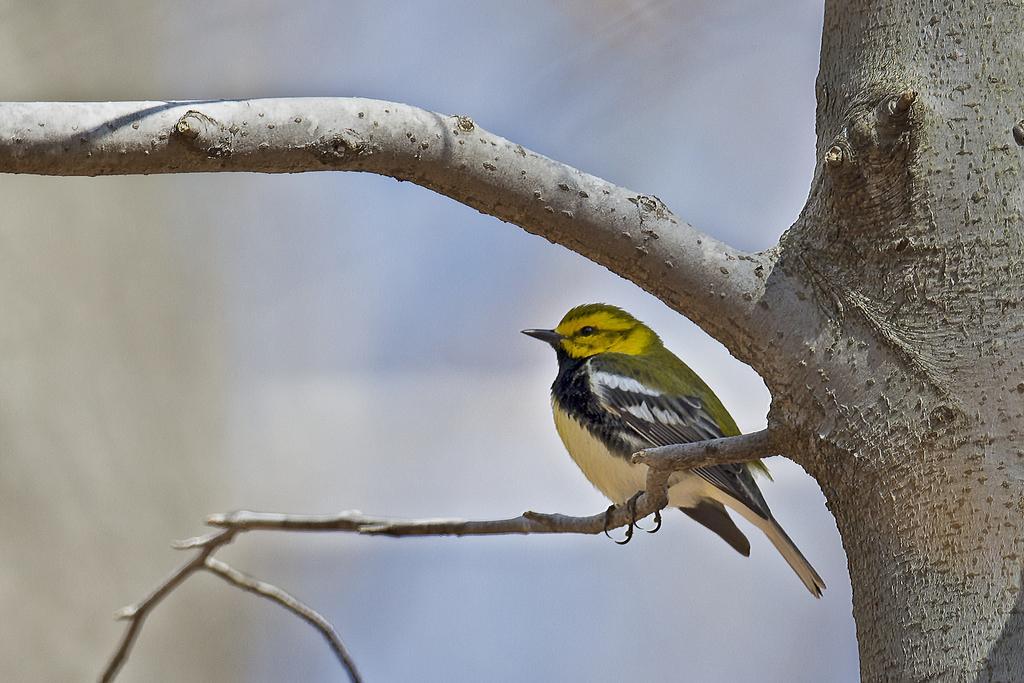Please provide a concise description of this image. In this image there is a bird on a tree, in the background it is blurred. 